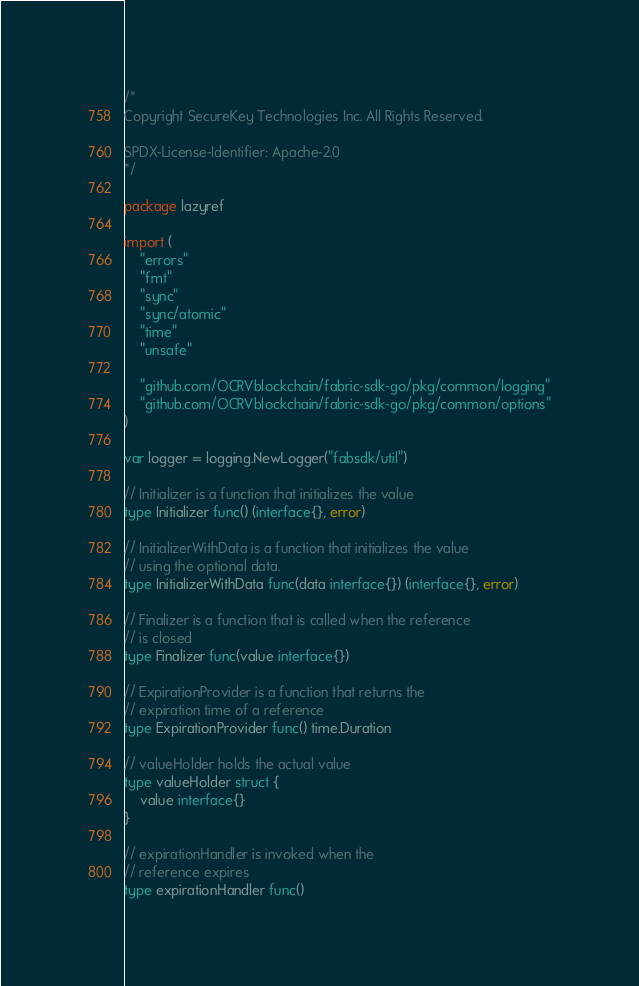<code> <loc_0><loc_0><loc_500><loc_500><_Go_>/*
Copyright SecureKey Technologies Inc. All Rights Reserved.

SPDX-License-Identifier: Apache-2.0
*/

package lazyref

import (
	"errors"
	"fmt"
	"sync"
	"sync/atomic"
	"time"
	"unsafe"

	"github.com/OCRVblockchain/fabric-sdk-go/pkg/common/logging"
	"github.com/OCRVblockchain/fabric-sdk-go/pkg/common/options"
)

var logger = logging.NewLogger("fabsdk/util")

// Initializer is a function that initializes the value
type Initializer func() (interface{}, error)

// InitializerWithData is a function that initializes the value
// using the optional data.
type InitializerWithData func(data interface{}) (interface{}, error)

// Finalizer is a function that is called when the reference
// is closed
type Finalizer func(value interface{})

// ExpirationProvider is a function that returns the
// expiration time of a reference
type ExpirationProvider func() time.Duration

// valueHolder holds the actual value
type valueHolder struct {
	value interface{}
}

// expirationHandler is invoked when the
// reference expires
type expirationHandler func()
</code> 